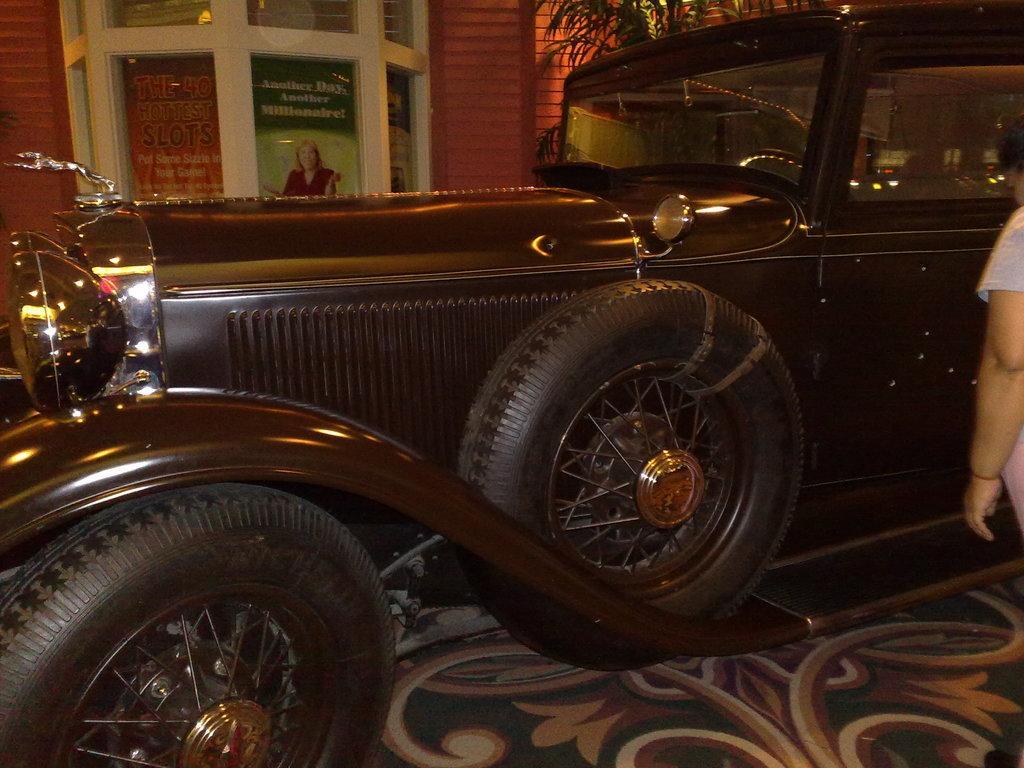Describe this image in one or two sentences. In this image there is an old vintage car, beside the car there is a person standing, on the other side of the car there is a glass window on the wall. 